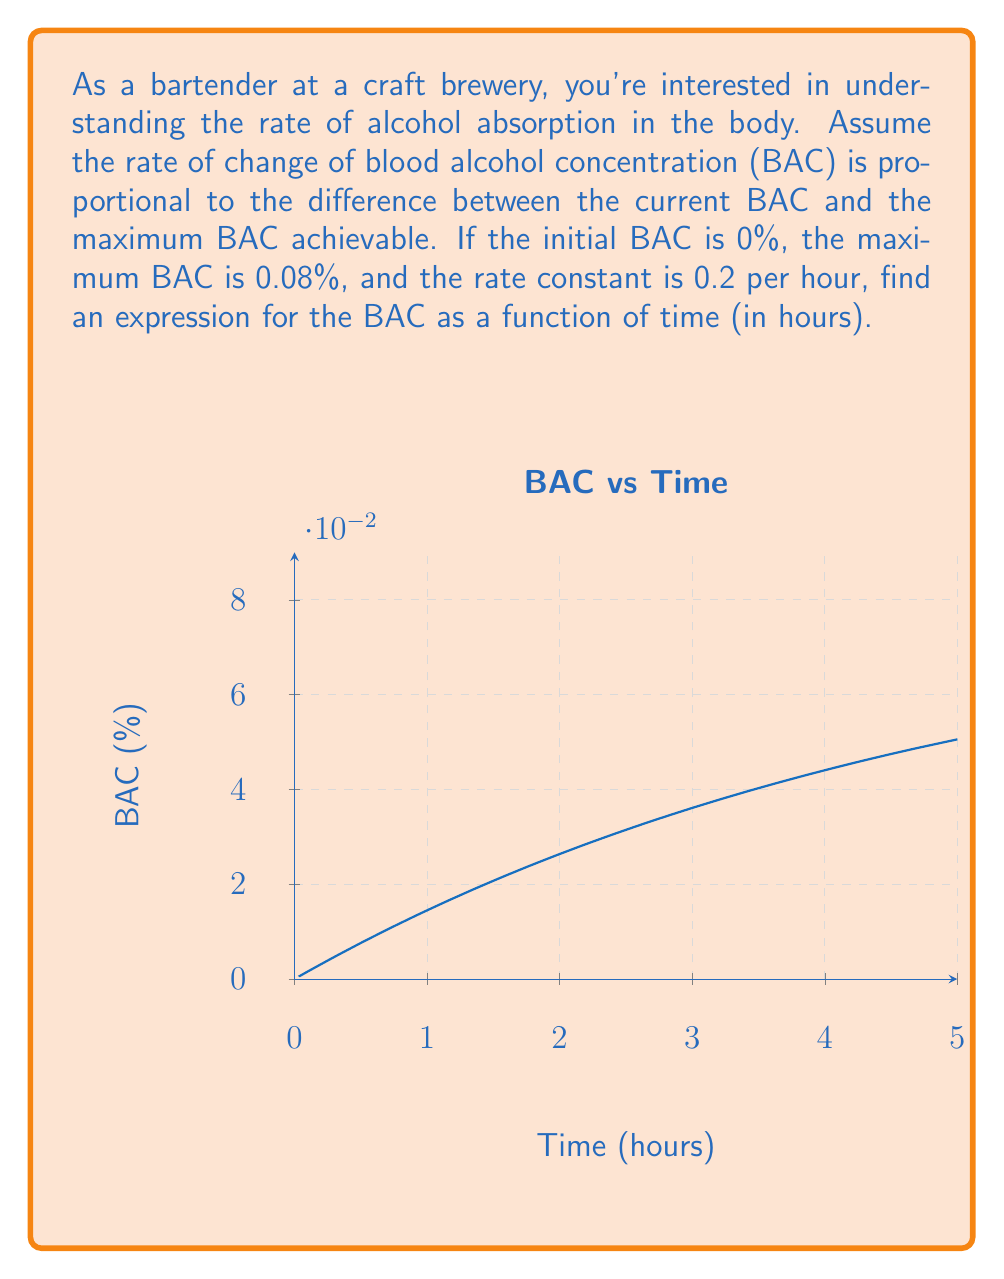Show me your answer to this math problem. Let's approach this step-by-step:

1) Let $B(t)$ be the BAC at time $t$. The problem describes a first-order differential equation:

   $$\frac{dB}{dt} = k(B_{max} - B)$$

   where $k$ is the rate constant and $B_{max}$ is the maximum BAC.

2) We're given:
   - $k = 0.2$ per hour
   - $B_{max} = 0.08$
   - $B(0) = 0$ (initial condition)

3) Rearranging the differential equation:

   $$\frac{dB}{B_{max} - B} = k dt$$

4) Integrating both sides:

   $$\int \frac{dB}{B_{max} - B} = \int k dt$$

5) This gives us:

   $$-\ln|B_{max} - B| = kt + C$$

6) Solving for $B$:

   $$B_{max} - B = e^{-kt-C} = Ae^{-kt}$$
   $$B = B_{max} - Ae^{-kt}$$

7) Using the initial condition $B(0) = 0$:

   $$0 = B_{max} - A$$
   $$A = B_{max} = 0.08$$

8) Therefore, the final solution is:

   $$B(t) = B_{max}(1 - e^{-kt}) = 0.08(1 - e^{-0.2t})$$

This equation represents the BAC as a function of time, where $t$ is in hours.
Answer: $B(t) = 0.08(1 - e^{-0.2t})$ 